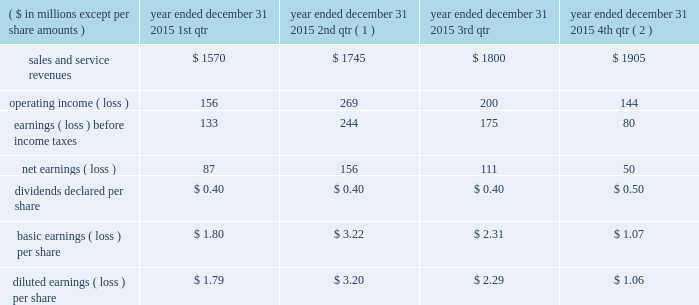Of exercise for stock options exercised or at period end for outstanding stock options , less the applicable exercise price .
The company issued new shares to satisfy exercised stock options .
Compensation expense the company recorded $ 43 million , $ 34 million , and $ 44 million of expense related to stock awards for the years ended december 31 , 2015 , 2014 , and 2013 , respectively .
The company recorded $ 17 million , $ 13 million , and $ 17 million as a tax benefit related to stock awards and stock options for the years ended december 31 , 2015 , 2014 , and 2013 , respectively .
The company recognized tax benefits for the years ended december 31 , 2015 , 2014 , and 2013 , of $ 41 million , $ 53 million , and $ 32 million , respectively , from the issuance of stock in settlement of stock awards , and $ 4 million , $ 5 million , and $ 4 million for the years ended december 31 , 2015 , 2014 , and 2013 , respectively , from the exercise of stock options .
Unrecognized compensation expense as of december 31 , 2015 , the company had less than $ 1 million of unrecognized compensation expense associated with rsrs granted in 2015 and 2014 , which will be recognized over a weighted average period of 1.0 year , and $ 25 million of unrecognized expense associated with rpsrs granted in 2015 , 2014 , and 2013 , which will be recognized over a weighted average period of 0.6 years .
As of december 31 , 2015 , the company had no unrecognized compensation expense related to stock options .
Compensation expense for stock options was fully recognized as of december 31 , 2013 .
20 .
Unaudited selected quarterly data unaudited quarterly financial results for the years ended december 31 , 2015 and 2014 , are set forth in the tables: .
( 1 ) in the second quarter of 2015 , the company recorded a $ 59 million goodwill impairment charge .
During the same period , the company recorded $ 136 million of operating income as a result of the aon settlement .
( 2 ) in the fourth quarter of 2015 , the company recorded $ 16 million goodwill impairment and $ 27 million intangible asset impairment charges. .
What was the total sales revenue in 2015 in millions? 
Rationale: the sales is the sum of all quarterly sales
Computations: ((1570 + 1745) + 1800)
Answer: 5115.0. 